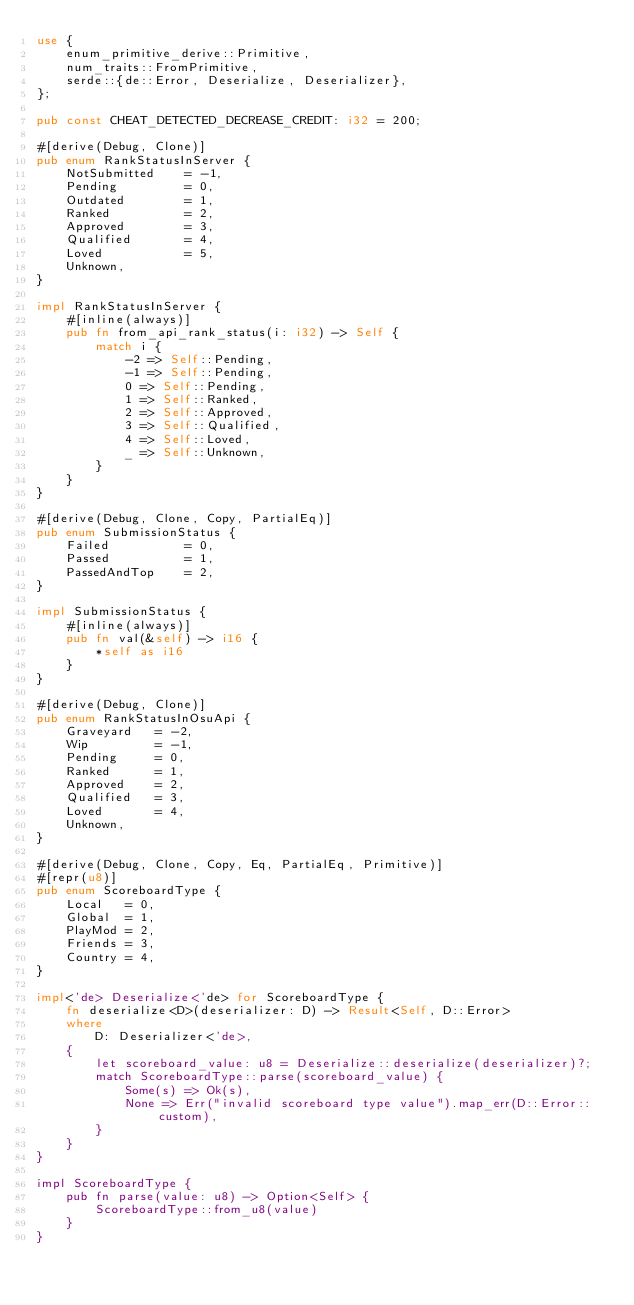Convert code to text. <code><loc_0><loc_0><loc_500><loc_500><_Rust_>use {
    enum_primitive_derive::Primitive,
    num_traits::FromPrimitive,
    serde::{de::Error, Deserialize, Deserializer},
};

pub const CHEAT_DETECTED_DECREASE_CREDIT: i32 = 200;

#[derive(Debug, Clone)]
pub enum RankStatusInServer {
    NotSubmitted    = -1,
    Pending         = 0,
    Outdated        = 1,
    Ranked          = 2,
    Approved        = 3,
    Qualified       = 4,
    Loved           = 5,
    Unknown,
}

impl RankStatusInServer {
    #[inline(always)]
    pub fn from_api_rank_status(i: i32) -> Self {
        match i {
            -2 => Self::Pending,
            -1 => Self::Pending,
            0 => Self::Pending,
            1 => Self::Ranked,
            2 => Self::Approved,
            3 => Self::Qualified,
            4 => Self::Loved,
            _ => Self::Unknown,
        }
    }
}

#[derive(Debug, Clone, Copy, PartialEq)]
pub enum SubmissionStatus {
    Failed          = 0,
    Passed          = 1,
    PassedAndTop    = 2,
}

impl SubmissionStatus {
    #[inline(always)]
    pub fn val(&self) -> i16 {
        *self as i16
    }
}

#[derive(Debug, Clone)]
pub enum RankStatusInOsuApi {
    Graveyard   = -2,
    Wip         = -1,
    Pending     = 0,
    Ranked      = 1,
    Approved    = 2,
    Qualified   = 3,
    Loved       = 4,
    Unknown,
}

#[derive(Debug, Clone, Copy, Eq, PartialEq, Primitive)]
#[repr(u8)]
pub enum ScoreboardType {
    Local   = 0,
    Global  = 1,
    PlayMod = 2,
    Friends = 3,
    Country = 4,
}

impl<'de> Deserialize<'de> for ScoreboardType {
    fn deserialize<D>(deserializer: D) -> Result<Self, D::Error>
    where
        D: Deserializer<'de>,
    {
        let scoreboard_value: u8 = Deserialize::deserialize(deserializer)?;
        match ScoreboardType::parse(scoreboard_value) {
            Some(s) => Ok(s),
            None => Err("invalid scoreboard type value").map_err(D::Error::custom),
        }
    }
}

impl ScoreboardType {
    pub fn parse(value: u8) -> Option<Self> {
        ScoreboardType::from_u8(value)
    }
}
</code> 